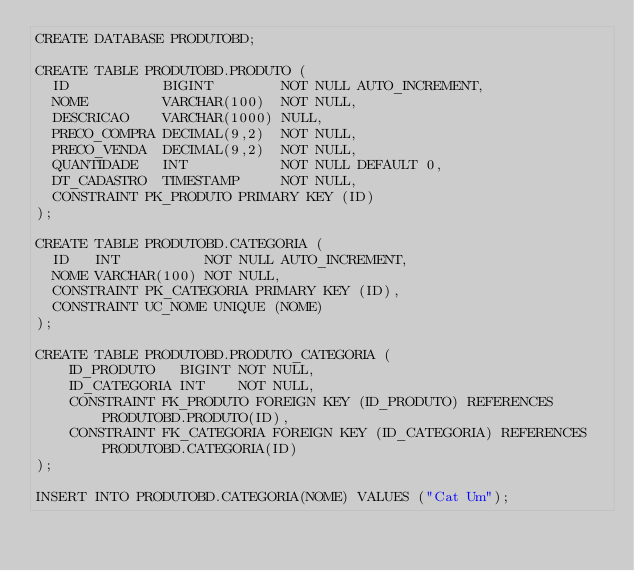<code> <loc_0><loc_0><loc_500><loc_500><_SQL_>CREATE DATABASE PRODUTOBD;

CREATE TABLE PRODUTOBD.PRODUTO (
  ID           BIGINT        NOT NULL AUTO_INCREMENT,
  NOME         VARCHAR(100)  NOT NULL,
  DESCRICAO    VARCHAR(1000) NULL,
  PRECO_COMPRA DECIMAL(9,2)  NOT NULL,
  PRECO_VENDA  DECIMAL(9,2)  NOT NULL,
  QUANTIDADE   INT           NOT NULL DEFAULT 0,
  DT_CADASTRO  TIMESTAMP     NOT NULL,
  CONSTRAINT PK_PRODUTO PRIMARY KEY (ID)
);

CREATE TABLE PRODUTOBD.CATEGORIA (
  ID   INT          NOT NULL AUTO_INCREMENT,
  NOME VARCHAR(100) NOT NULL,
  CONSTRAINT PK_CATEGORIA PRIMARY KEY (ID),
  CONSTRAINT UC_NOME UNIQUE (NOME)
);

CREATE TABLE PRODUTOBD.PRODUTO_CATEGORIA (
    ID_PRODUTO   BIGINT NOT NULL,
    ID_CATEGORIA INT    NOT NULL,
    CONSTRAINT FK_PRODUTO FOREIGN KEY (ID_PRODUTO) REFERENCES PRODUTOBD.PRODUTO(ID),
    CONSTRAINT FK_CATEGORIA FOREIGN KEY (ID_CATEGORIA) REFERENCES PRODUTOBD.CATEGORIA(ID)
);

INSERT INTO PRODUTOBD.CATEGORIA(NOME) VALUES ("Cat Um");</code> 